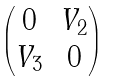Convert formula to latex. <formula><loc_0><loc_0><loc_500><loc_500>\begin{pmatrix} 0 & V _ { 2 } \\ V _ { 3 } & 0 \end{pmatrix}</formula> 